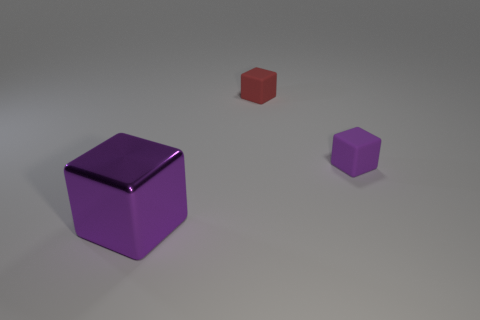There is a purple cube that is on the right side of the purple metallic block; how many things are in front of it?
Provide a succinct answer. 1. There is a small purple rubber block; are there any red matte cubes on the right side of it?
Provide a short and direct response. No. Is the shape of the purple object to the right of the big metallic cube the same as  the red rubber thing?
Your answer should be compact. Yes. There is another block that is the same color as the metal cube; what material is it?
Give a very brief answer. Rubber. How many small metal cylinders have the same color as the big block?
Your response must be concise. 0. What shape is the thing behind the purple cube that is right of the purple shiny cube?
Offer a terse response. Cube. Is there another red object that has the same shape as the shiny thing?
Provide a succinct answer. Yes. Is the color of the metallic thing the same as the tiny block to the right of the red object?
Offer a very short reply. Yes. What size is the other matte object that is the same color as the large thing?
Keep it short and to the point. Small. Is there a red cube that has the same size as the red matte object?
Your answer should be very brief. No. 